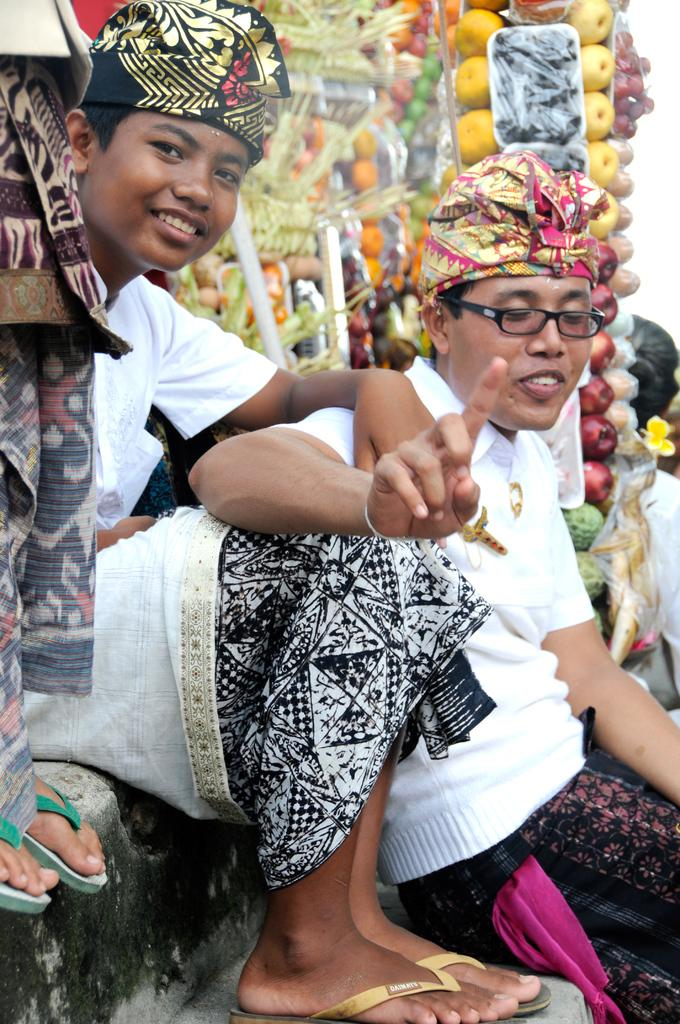Who or what can be seen in the image? There are people in the image. What else is present in the image besides people? There are fruits and objects in the image. How are the people positioned in the image? Two people are sitting in the image. Can you describe the appearance of one of the people? One person in the image is wearing spectacles. What type of holiday is being celebrated in the image? There is no indication of a holiday being celebrated in the image. How many cars can be seen in the image? There are no cars present in the image. 